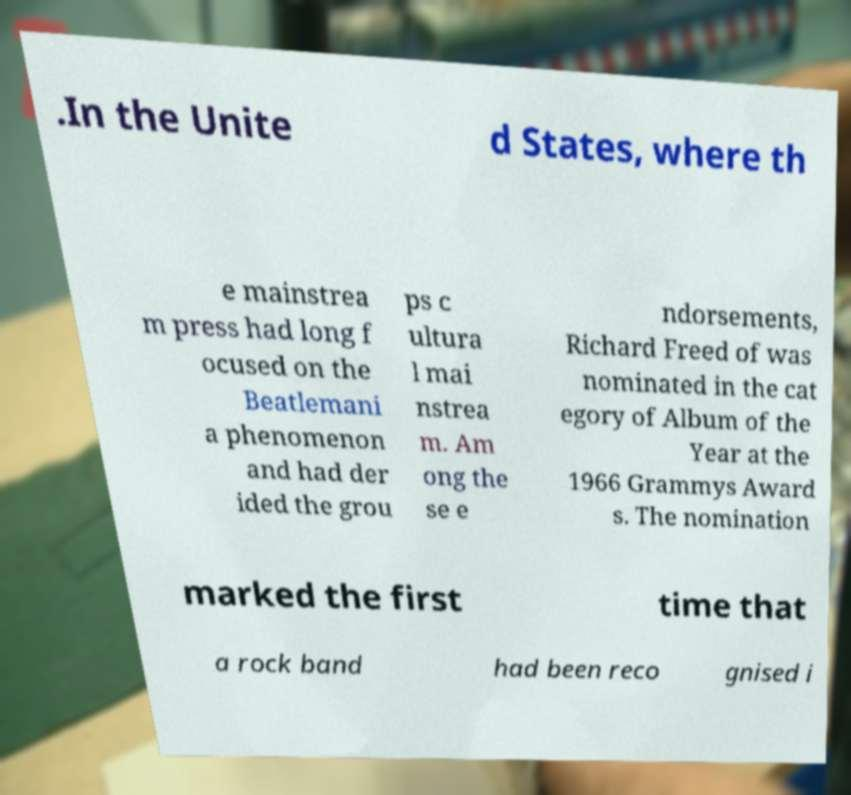Please read and relay the text visible in this image. What does it say? .In the Unite d States, where th e mainstrea m press had long f ocused on the Beatlemani a phenomenon and had der ided the grou ps c ultura l mai nstrea m. Am ong the se e ndorsements, Richard Freed of was nominated in the cat egory of Album of the Year at the 1966 Grammys Award s. The nomination marked the first time that a rock band had been reco gnised i 